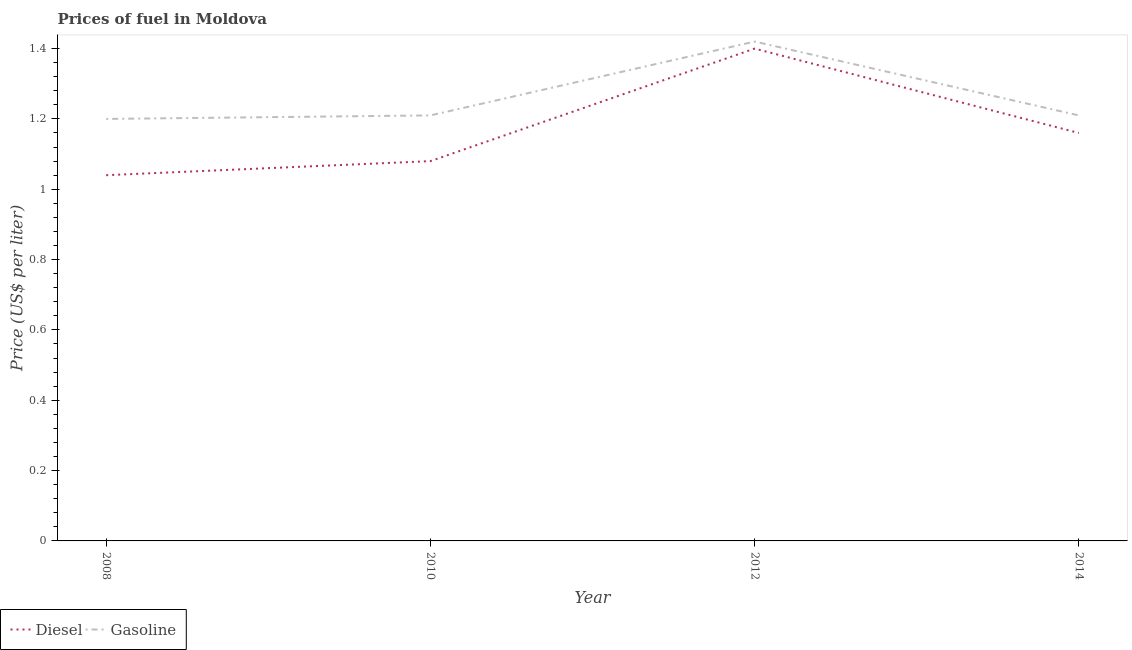Does the line corresponding to diesel price intersect with the line corresponding to gasoline price?
Offer a terse response. No. Is the number of lines equal to the number of legend labels?
Provide a short and direct response. Yes. What is the gasoline price in 2014?
Provide a succinct answer. 1.21. Across all years, what is the minimum diesel price?
Keep it short and to the point. 1.04. In which year was the diesel price minimum?
Provide a short and direct response. 2008. What is the total diesel price in the graph?
Ensure brevity in your answer.  4.68. What is the difference between the diesel price in 2008 and that in 2010?
Keep it short and to the point. -0.04. What is the difference between the gasoline price in 2014 and the diesel price in 2010?
Offer a very short reply. 0.13. What is the average gasoline price per year?
Your answer should be very brief. 1.26. In the year 2010, what is the difference between the diesel price and gasoline price?
Give a very brief answer. -0.13. In how many years, is the diesel price greater than 0.4 US$ per litre?
Offer a very short reply. 4. What is the ratio of the gasoline price in 2008 to that in 2010?
Offer a very short reply. 0.99. What is the difference between the highest and the second highest gasoline price?
Your response must be concise. 0.21. What is the difference between the highest and the lowest diesel price?
Make the answer very short. 0.36. How many lines are there?
Your response must be concise. 2. Does the graph contain grids?
Your response must be concise. No. Where does the legend appear in the graph?
Keep it short and to the point. Bottom left. How are the legend labels stacked?
Keep it short and to the point. Horizontal. What is the title of the graph?
Keep it short and to the point. Prices of fuel in Moldova. What is the label or title of the Y-axis?
Your answer should be very brief. Price (US$ per liter). What is the Price (US$ per liter) in Gasoline in 2008?
Offer a terse response. 1.2. What is the Price (US$ per liter) in Diesel in 2010?
Your response must be concise. 1.08. What is the Price (US$ per liter) of Gasoline in 2010?
Offer a very short reply. 1.21. What is the Price (US$ per liter) in Gasoline in 2012?
Give a very brief answer. 1.42. What is the Price (US$ per liter) of Diesel in 2014?
Provide a short and direct response. 1.16. What is the Price (US$ per liter) of Gasoline in 2014?
Your response must be concise. 1.21. Across all years, what is the maximum Price (US$ per liter) of Gasoline?
Provide a short and direct response. 1.42. Across all years, what is the minimum Price (US$ per liter) in Gasoline?
Give a very brief answer. 1.2. What is the total Price (US$ per liter) in Diesel in the graph?
Make the answer very short. 4.68. What is the total Price (US$ per liter) of Gasoline in the graph?
Provide a succinct answer. 5.04. What is the difference between the Price (US$ per liter) in Diesel in 2008 and that in 2010?
Offer a terse response. -0.04. What is the difference between the Price (US$ per liter) in Gasoline in 2008 and that in 2010?
Your answer should be compact. -0.01. What is the difference between the Price (US$ per liter) of Diesel in 2008 and that in 2012?
Your response must be concise. -0.36. What is the difference between the Price (US$ per liter) in Gasoline in 2008 and that in 2012?
Your response must be concise. -0.22. What is the difference between the Price (US$ per liter) of Diesel in 2008 and that in 2014?
Give a very brief answer. -0.12. What is the difference between the Price (US$ per liter) of Gasoline in 2008 and that in 2014?
Your answer should be very brief. -0.01. What is the difference between the Price (US$ per liter) of Diesel in 2010 and that in 2012?
Give a very brief answer. -0.32. What is the difference between the Price (US$ per liter) in Gasoline in 2010 and that in 2012?
Give a very brief answer. -0.21. What is the difference between the Price (US$ per liter) in Diesel in 2010 and that in 2014?
Provide a short and direct response. -0.08. What is the difference between the Price (US$ per liter) in Gasoline in 2010 and that in 2014?
Provide a succinct answer. 0. What is the difference between the Price (US$ per liter) in Diesel in 2012 and that in 2014?
Offer a terse response. 0.24. What is the difference between the Price (US$ per liter) in Gasoline in 2012 and that in 2014?
Your answer should be compact. 0.21. What is the difference between the Price (US$ per liter) in Diesel in 2008 and the Price (US$ per liter) in Gasoline in 2010?
Make the answer very short. -0.17. What is the difference between the Price (US$ per liter) of Diesel in 2008 and the Price (US$ per liter) of Gasoline in 2012?
Give a very brief answer. -0.38. What is the difference between the Price (US$ per liter) in Diesel in 2008 and the Price (US$ per liter) in Gasoline in 2014?
Ensure brevity in your answer.  -0.17. What is the difference between the Price (US$ per liter) of Diesel in 2010 and the Price (US$ per liter) of Gasoline in 2012?
Offer a terse response. -0.34. What is the difference between the Price (US$ per liter) of Diesel in 2010 and the Price (US$ per liter) of Gasoline in 2014?
Provide a succinct answer. -0.13. What is the difference between the Price (US$ per liter) in Diesel in 2012 and the Price (US$ per liter) in Gasoline in 2014?
Your response must be concise. 0.19. What is the average Price (US$ per liter) of Diesel per year?
Your answer should be compact. 1.17. What is the average Price (US$ per liter) in Gasoline per year?
Offer a very short reply. 1.26. In the year 2008, what is the difference between the Price (US$ per liter) in Diesel and Price (US$ per liter) in Gasoline?
Provide a short and direct response. -0.16. In the year 2010, what is the difference between the Price (US$ per liter) of Diesel and Price (US$ per liter) of Gasoline?
Keep it short and to the point. -0.13. In the year 2012, what is the difference between the Price (US$ per liter) in Diesel and Price (US$ per liter) in Gasoline?
Provide a short and direct response. -0.02. In the year 2014, what is the difference between the Price (US$ per liter) in Diesel and Price (US$ per liter) in Gasoline?
Offer a very short reply. -0.05. What is the ratio of the Price (US$ per liter) in Diesel in 2008 to that in 2010?
Your response must be concise. 0.96. What is the ratio of the Price (US$ per liter) in Gasoline in 2008 to that in 2010?
Offer a terse response. 0.99. What is the ratio of the Price (US$ per liter) in Diesel in 2008 to that in 2012?
Your answer should be very brief. 0.74. What is the ratio of the Price (US$ per liter) of Gasoline in 2008 to that in 2012?
Your response must be concise. 0.85. What is the ratio of the Price (US$ per liter) of Diesel in 2008 to that in 2014?
Make the answer very short. 0.9. What is the ratio of the Price (US$ per liter) of Diesel in 2010 to that in 2012?
Provide a short and direct response. 0.77. What is the ratio of the Price (US$ per liter) of Gasoline in 2010 to that in 2012?
Give a very brief answer. 0.85. What is the ratio of the Price (US$ per liter) in Diesel in 2012 to that in 2014?
Offer a very short reply. 1.21. What is the ratio of the Price (US$ per liter) in Gasoline in 2012 to that in 2014?
Your answer should be very brief. 1.17. What is the difference between the highest and the second highest Price (US$ per liter) in Diesel?
Ensure brevity in your answer.  0.24. What is the difference between the highest and the second highest Price (US$ per liter) in Gasoline?
Keep it short and to the point. 0.21. What is the difference between the highest and the lowest Price (US$ per liter) of Diesel?
Ensure brevity in your answer.  0.36. What is the difference between the highest and the lowest Price (US$ per liter) of Gasoline?
Ensure brevity in your answer.  0.22. 